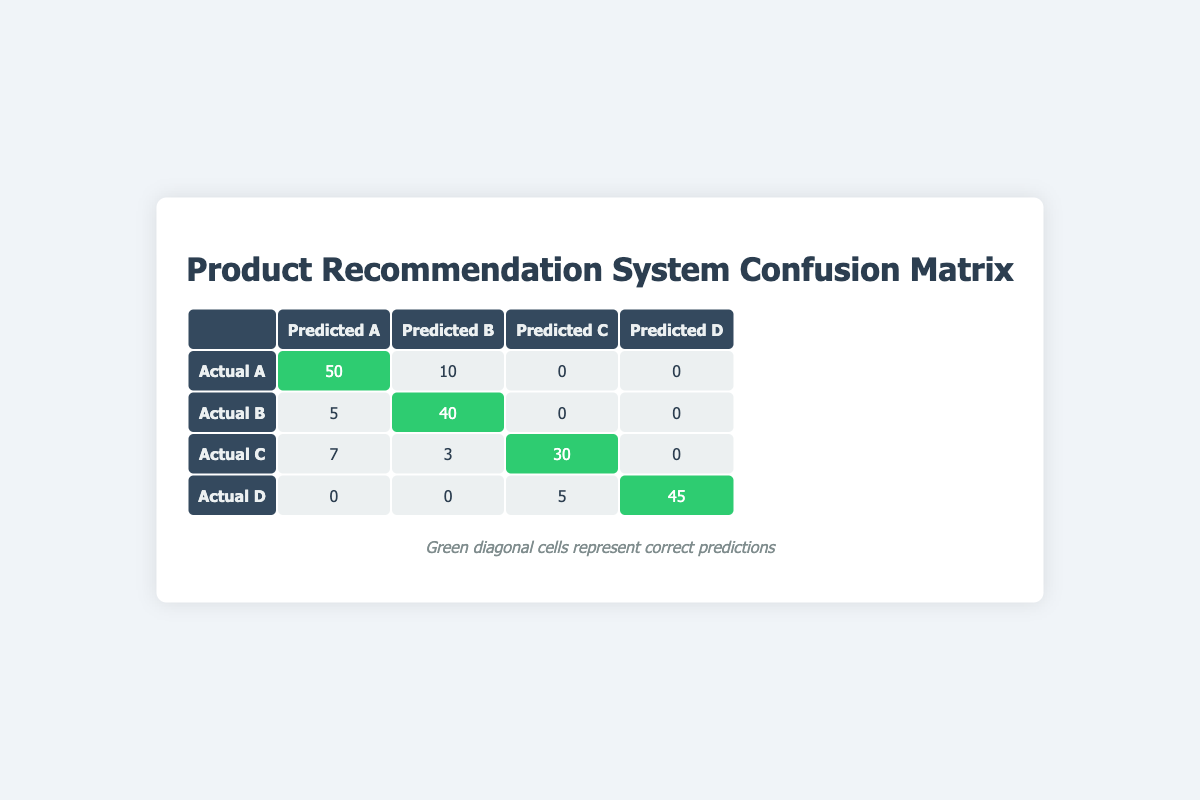What is the total number of actual recommendations for Item A? In the table, we see two rows related to Item A: one row for actual A predicted as A (50) and another for actual A predicted as B (10). Adding these counts gives 50 + 10 = 60.
Answer: 60 What is the accuracy of the product recommendation system for Item B? The accuracy for any item is calculated by taking the correctly predicted values over the total number of actual occurrences. For Item B, the correct predictions (diagonal cell) are 40 and the total occurrences are 5 + 40 = 45. Thus, accuracy = 40 / 45 = 0.89 or 89%.
Answer: 89% Which actual item received the highest number of correct recommendations? We look at the diagonal values for each item: Item A has 50, Item B has 40, Item C has 30, and Item D has 45. The highest among these is 50 for Item A, indicating it had the highest correct recommendations.
Answer: Item A Is there any item that received more recommendations than it should have? We check if there are any off-diagonal predictions. For Item A, 10 predicted as B, for Item B, 5 predicted as A, for Item C, 7 predicted as A and 3 predicted as B. Thus, there are multiple off-diagonal predictions, indicating over-recommendation instances.
Answer: Yes What percentage of the total recommendations were correct predictions? First, calculate the total recommendations by summing all counts (50+10+5+40+7+3+30+45+5 = 195). Correct predictions total to (50 + 40 + 30 + 45 = 165). Thus, the percentage is (165/195) * 100 ≈ 84.62%.
Answer: 84.62% 